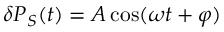<formula> <loc_0><loc_0><loc_500><loc_500>\delta P _ { S } ( t ) = A \cos ( \omega t + \varphi )</formula> 